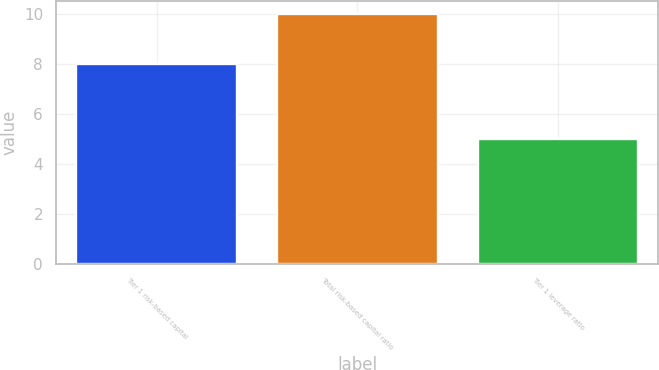Convert chart. <chart><loc_0><loc_0><loc_500><loc_500><bar_chart><fcel>Tier 1 risk-based capital<fcel>Total risk-based capital ratio<fcel>Tier 1 leverage ratio<nl><fcel>8<fcel>10<fcel>5<nl></chart> 